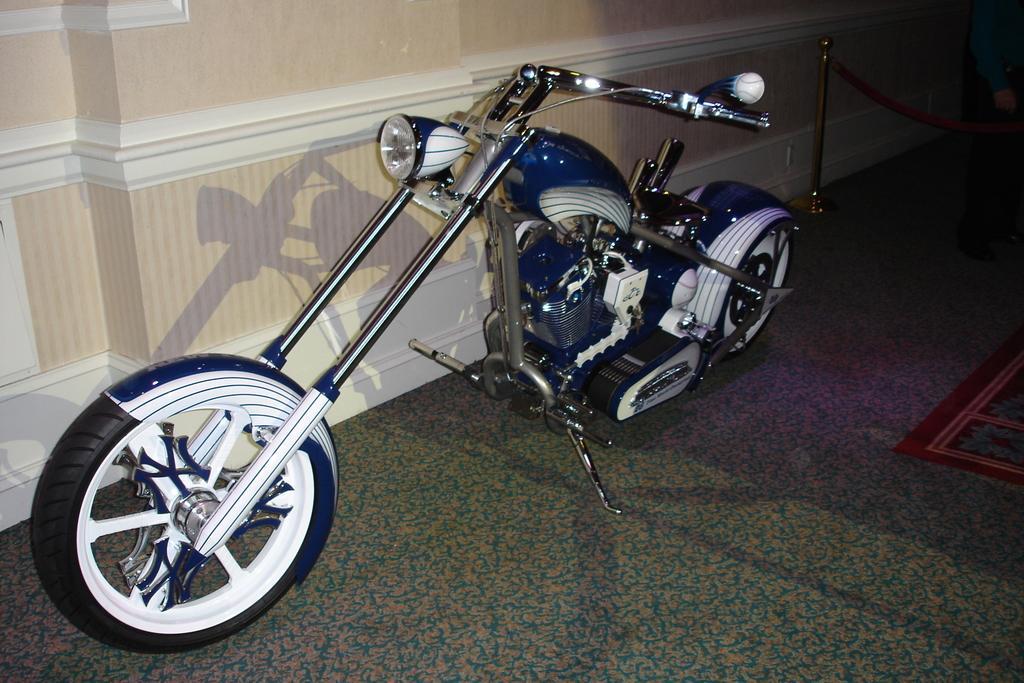Describe this image in one or two sentences. In the middle of the picture we can see a motorbike. At the bottom it is floor. At the top it is well. 